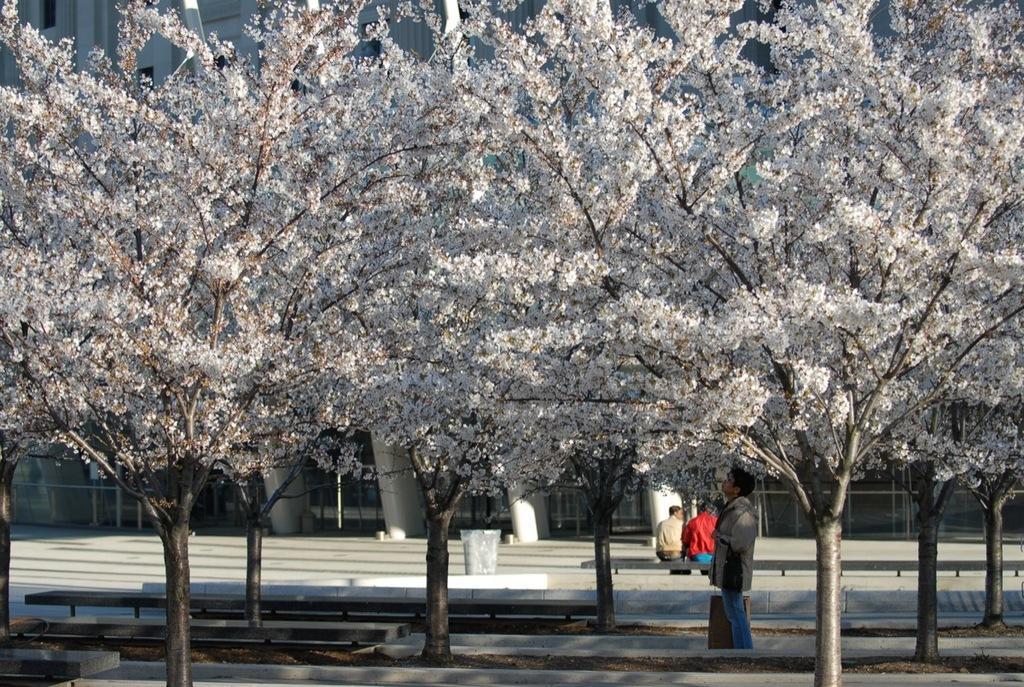Can you describe this image briefly? In this picture we can see few trees, flowers and group of people, few are seated on the bench, in the background we can see few buildings and a dustbin. 